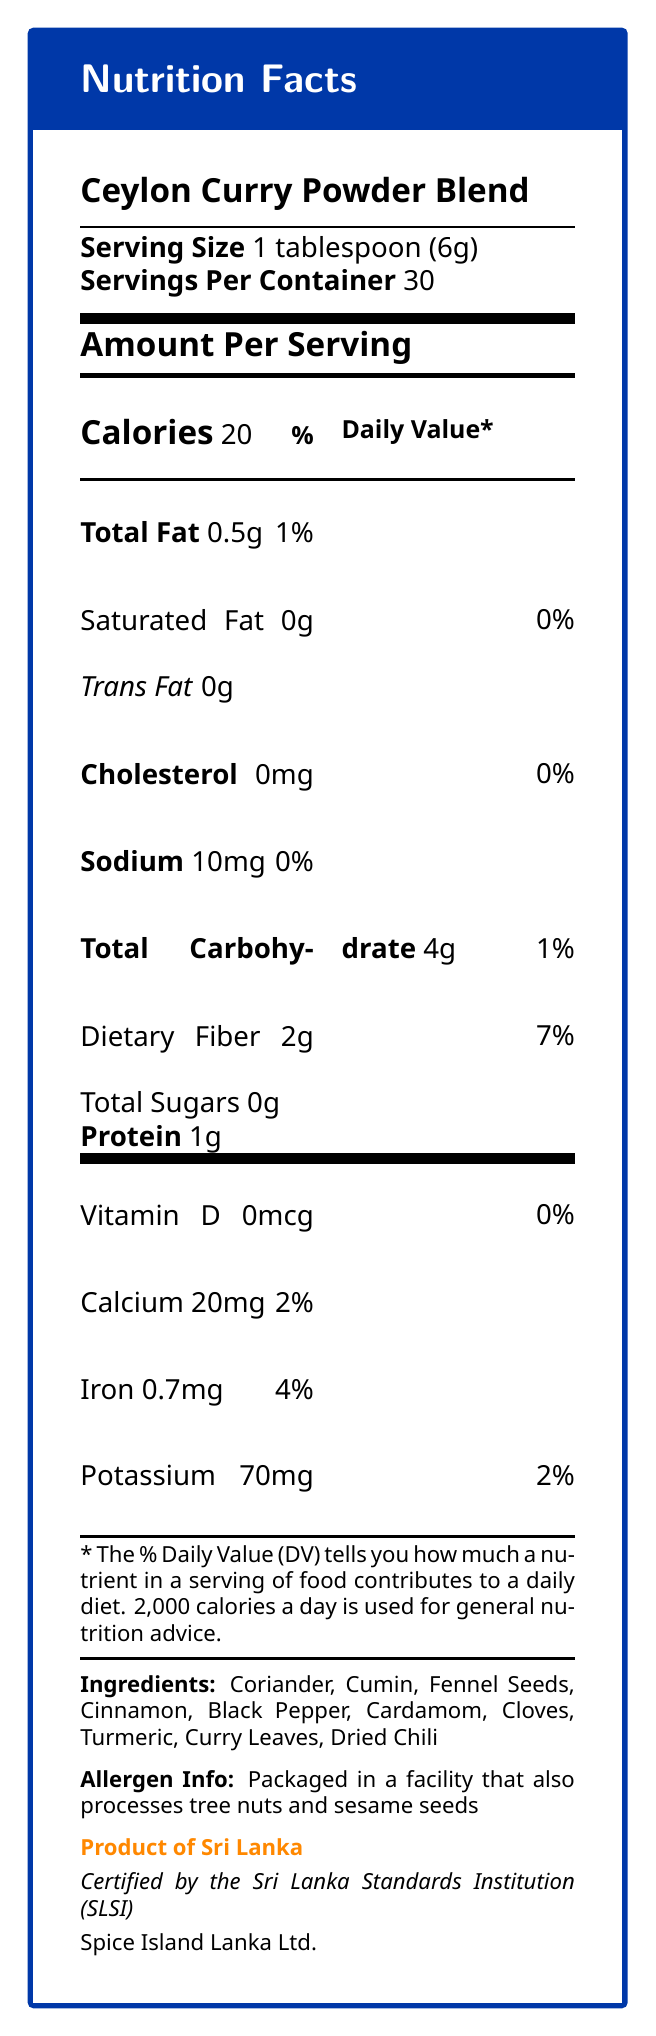what is the serving size of the Ceylon Curry Powder Blend? The serving size is explicitly stated in the document as 1 tablespoon, which is equivalent to 6 grams.
Answer: 1 tablespoon (6g) how many servings are there in one container? According to the document, there are 30 servings per container.
Answer: 30 how many calories are in one serving of the Ceylon Curry Powder Blend? The calories per serving are given as 20 in the document.
Answer: 20 what percentage of the daily value of dietary fiber does one serving provide? The document mentions that one serving provides 7% of the daily value of dietary fiber.
Answer: 7% what are the primary ingredients in the Ceylon Curry Powder Blend? The primary ingredients are listed explicitly in the document.
Answer: Coriander, Cumin, Fennel Seeds, Cinnamon, Black Pepper, Cardamom, Cloves, Turmeric, Curry Leaves, Dried Chili how much iron does one serving contain? A. 0.2mg B. 0.7mg C. 1mg D. 1.5mg The document lists iron content in one serving as 0.7mg.
Answer: B. 0.7mg what is the certification for the Ceylon Curry Powder Blend? A. Certified Organic B. Certified by the FDA C. Certified Gluten-Free D. Certified by the Sri Lanka Standards Institution (SLSI) The document states that the product is certified by the Sri Lanka Standards Institution (SLSI).
Answer: D. Certified by the Sri Lanka Standards Institution (SLSI) is the product free of saturated fat? The document indicates that there is 0g of saturated fat in one serving, so the product is free of saturated fat.
Answer: Yes summarize the nutritional content and origin information of the Ceylon Curry Powder Blend. The document outlines specific nutritional values per serving and lists the ingredients. It also mentions the certification and the origin of the product.
Answer: The Ceylon Curry Powder Blend provides 20 calories per serving, with 0.5g total fat (1% DV), 0g saturated fat, 0mg cholesterol, 10mg sodium (0% DV), 4g total carbohydrates (1% DV), 2g dietary fiber (7% DV), 0g total sugars, 1g protein, 0mcg Vitamin D (0% DV), 20mg calcium (2% DV), 0.7mg iron (4% DV), and 70mg potassium (2% DV). It contains ingredients such as coriander, cumin, fennel seeds, cinnamon, black pepper, cardamom, cloves, turmeric, curry leaves, and dried chili. The product is certified by the Sri Lanka Standards Institution (SLSI) and is a product of Sri Lanka. how many grams of protein are in one serving? The document indicates that one serving contains 1 gram of protein.
Answer: 1g how much sodium is in one serving? The document states that there is 10mg of sodium in one serving.
Answer: 10mg are there any allergens in the Ceylon Curry Powder Blend? The document notes that the product is packaged in a facility that also processes tree nuts and sesame seeds.
Answer: Packaged in a facility that also processes tree nuts and sesame seeds what is the total carbohydrate content in one serving? The document lists the total carbohydrate content as 4 grams per serving.
Answer: 4g does the Ceylon Curry Powder Blend contain any trans fat? The document indicates that the trans fat content is 0g, meaning it does not contain any trans fat.
Answer: No how should the Ceylon Curry Powder Blend be stored? The storage instructions in the document advise keeping the product in a cool, dry place away from direct sunlight.
Answer: Store in a cool, dry place away from direct sunlight what is the name of the manufacturer of the Ceylon Curry Powder Blend? The document lists Spice Island Lanka Ltd. as the manufacturer.
Answer: Spice Island Lanka Ltd. what is the main culinary use of the Ceylon Curry Powder Blend? The usage suggestions in the document highlight its use in traditional Sri Lankan dishes like chicken curry, dhal curry, and vegetable curries.
Answer: Use in traditional Sri Lankan dishes such as chicken curry, dhal curry, and vegetable curries how much potassium does one serving of the Ceylon Curry Powder Blend provide? The document lists the potassium content as 70mg per serving.
Answer: 70mg what is the primary spice in the blend? The document lists several spices but does not specify a primary spice among them.
Answer: Cannot be determined does one serving of the Ceylon Curry Powder Blend provide any Vitamin D? The document indicates that there is 0mcg Vitamin D, meaning one serving does not provide any Vitamin D.
Answer: No 